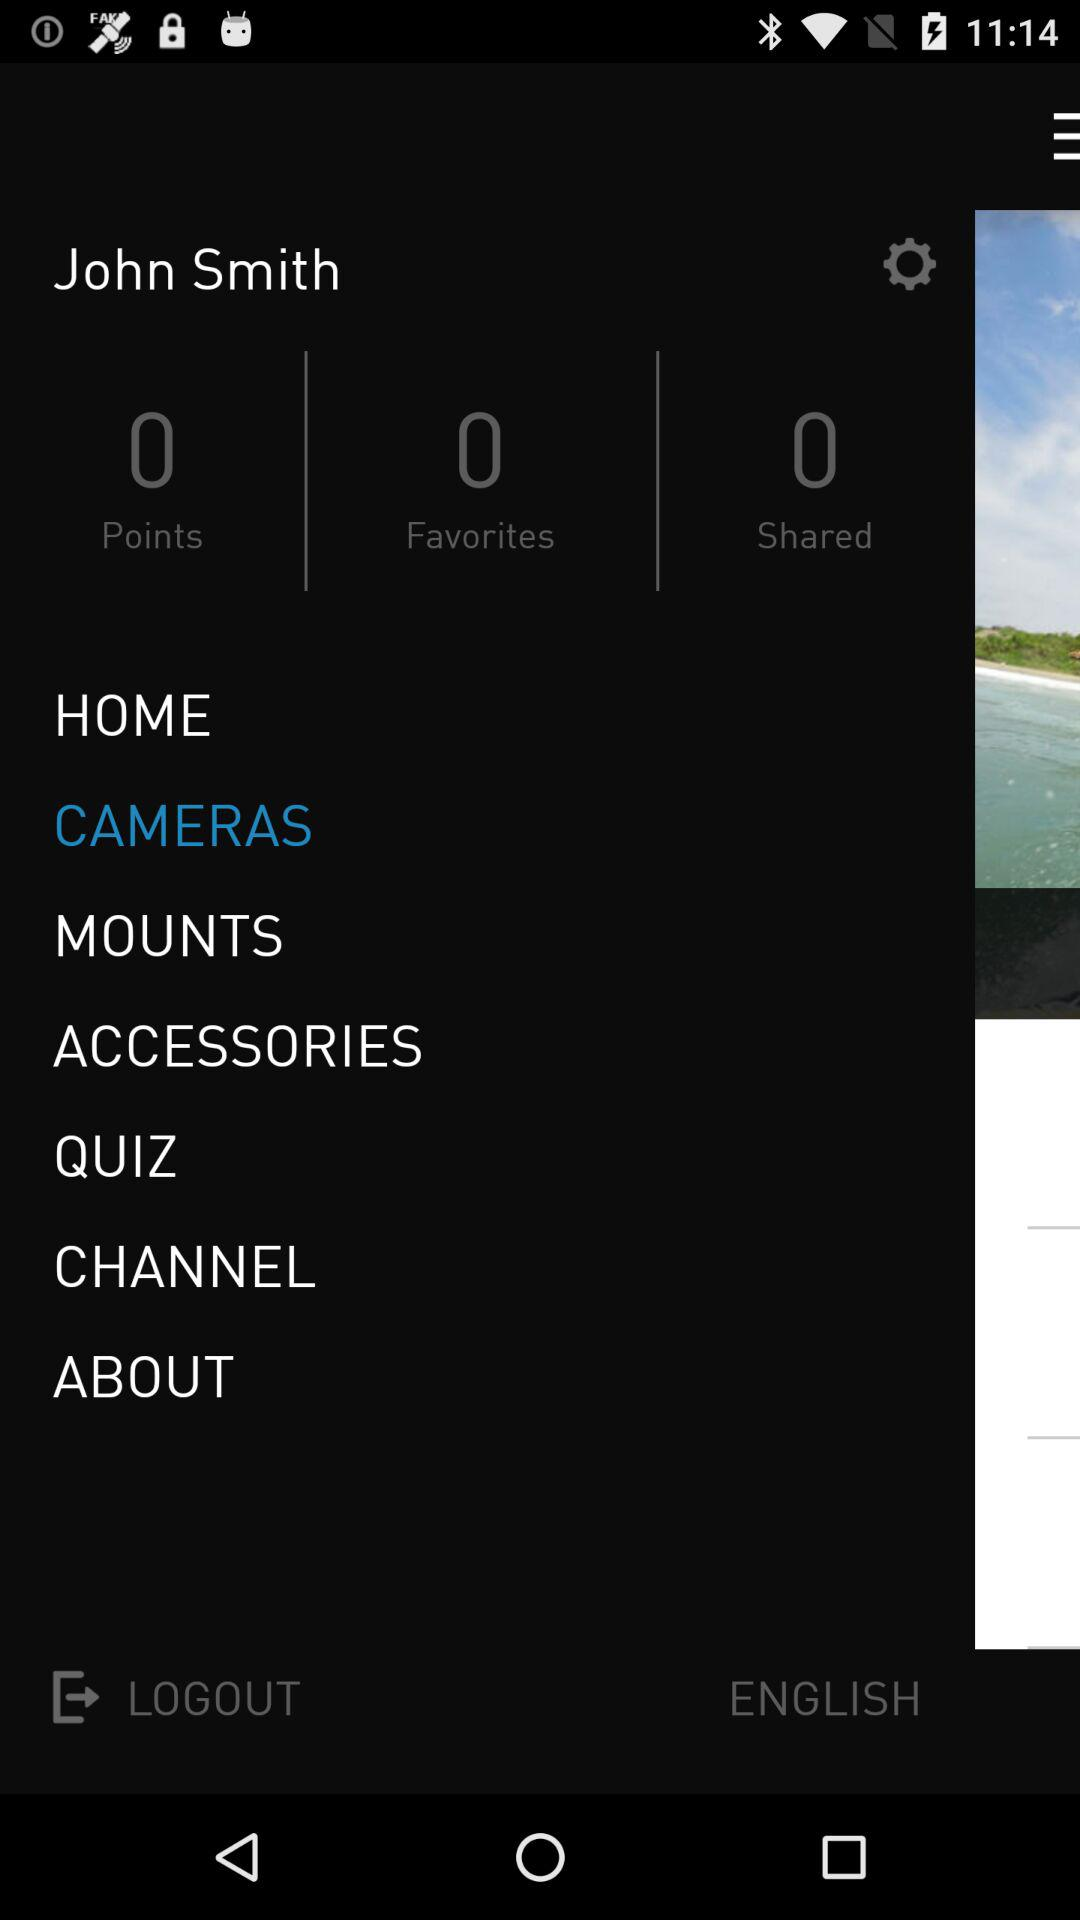What is the count of the favorites? The count of favorites is 0. 